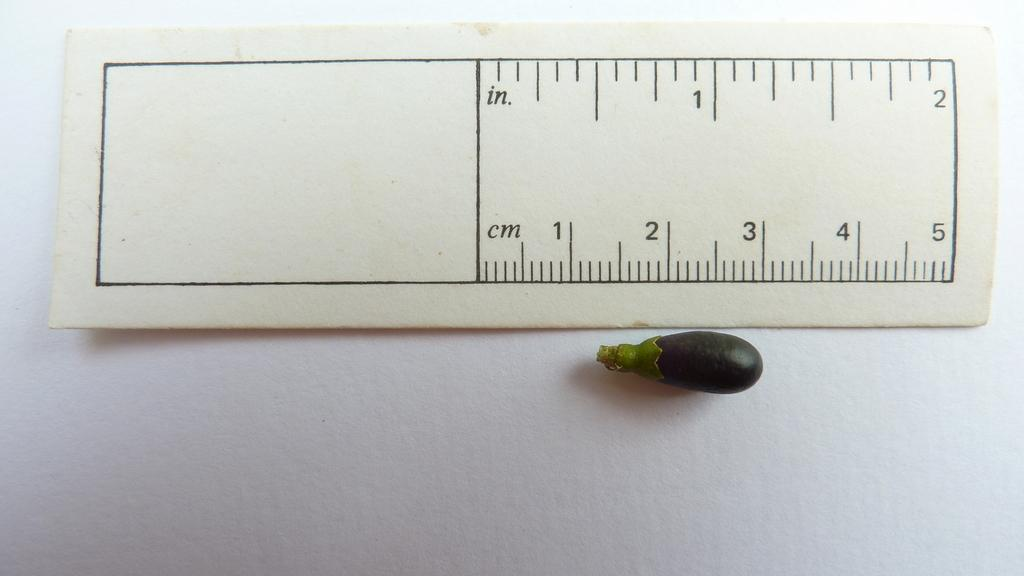<image>
Provide a brief description of the given image. A ruler has in with 1 and 2 and cm with 1 - 5. 